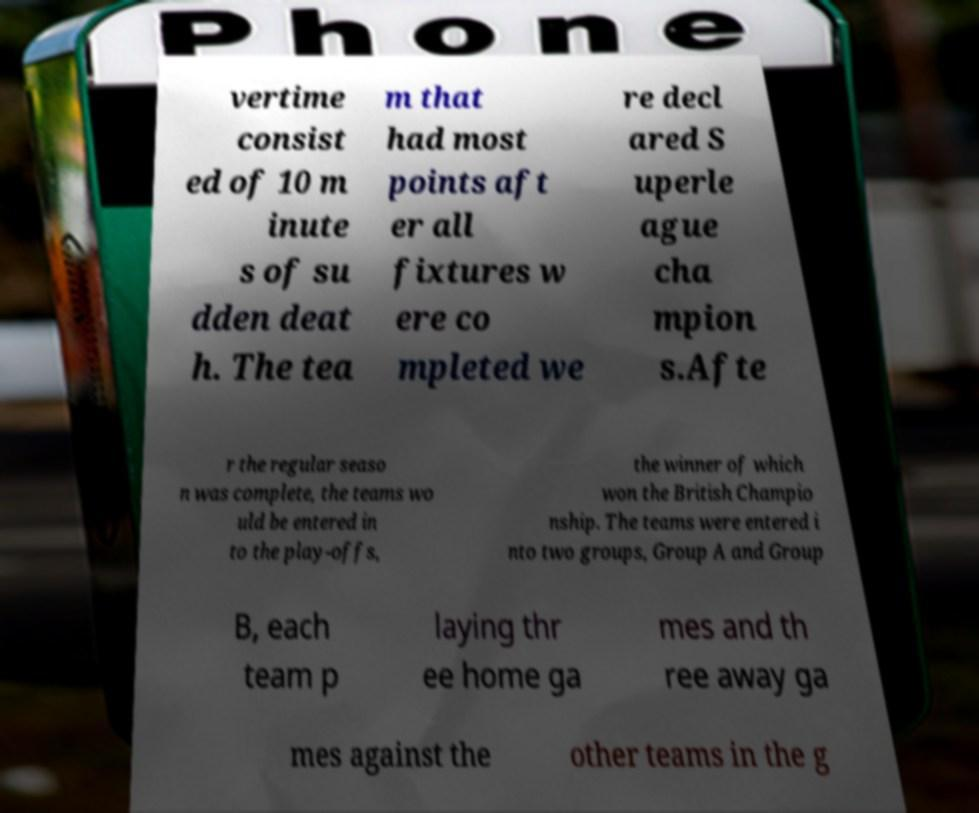I need the written content from this picture converted into text. Can you do that? vertime consist ed of 10 m inute s of su dden deat h. The tea m that had most points aft er all fixtures w ere co mpleted we re decl ared S uperle ague cha mpion s.Afte r the regular seaso n was complete, the teams wo uld be entered in to the play-offs, the winner of which won the British Champio nship. The teams were entered i nto two groups, Group A and Group B, each team p laying thr ee home ga mes and th ree away ga mes against the other teams in the g 